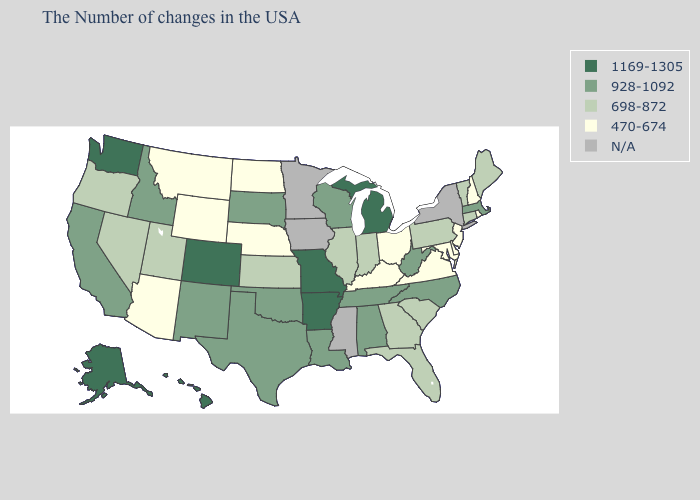What is the value of Massachusetts?
Keep it brief. 928-1092. What is the highest value in the South ?
Write a very short answer. 1169-1305. Name the states that have a value in the range 470-674?
Be succinct. Rhode Island, New Hampshire, New Jersey, Delaware, Maryland, Virginia, Ohio, Kentucky, Nebraska, North Dakota, Wyoming, Montana, Arizona. Among the states that border Idaho , does Washington have the highest value?
Quick response, please. Yes. What is the highest value in states that border Wisconsin?
Quick response, please. 1169-1305. Which states have the lowest value in the USA?
Answer briefly. Rhode Island, New Hampshire, New Jersey, Delaware, Maryland, Virginia, Ohio, Kentucky, Nebraska, North Dakota, Wyoming, Montana, Arizona. Which states have the lowest value in the USA?
Answer briefly. Rhode Island, New Hampshire, New Jersey, Delaware, Maryland, Virginia, Ohio, Kentucky, Nebraska, North Dakota, Wyoming, Montana, Arizona. Name the states that have a value in the range 470-674?
Be succinct. Rhode Island, New Hampshire, New Jersey, Delaware, Maryland, Virginia, Ohio, Kentucky, Nebraska, North Dakota, Wyoming, Montana, Arizona. What is the lowest value in the USA?
Write a very short answer. 470-674. Name the states that have a value in the range N/A?
Short answer required. New York, Mississippi, Minnesota, Iowa. How many symbols are there in the legend?
Be succinct. 5. Name the states that have a value in the range 928-1092?
Quick response, please. Massachusetts, North Carolina, West Virginia, Alabama, Tennessee, Wisconsin, Louisiana, Oklahoma, Texas, South Dakota, New Mexico, Idaho, California. Name the states that have a value in the range 470-674?
Quick response, please. Rhode Island, New Hampshire, New Jersey, Delaware, Maryland, Virginia, Ohio, Kentucky, Nebraska, North Dakota, Wyoming, Montana, Arizona. What is the value of Nebraska?
Answer briefly. 470-674. 